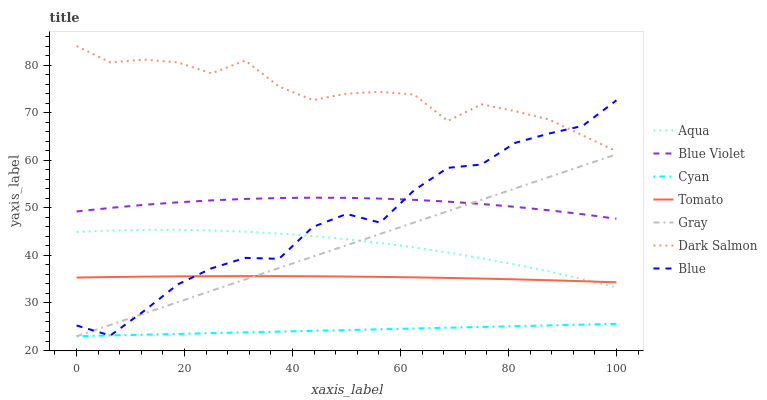Does Cyan have the minimum area under the curve?
Answer yes or no. Yes. Does Dark Salmon have the maximum area under the curve?
Answer yes or no. Yes. Does Gray have the minimum area under the curve?
Answer yes or no. No. Does Gray have the maximum area under the curve?
Answer yes or no. No. Is Cyan the smoothest?
Answer yes or no. Yes. Is Blue the roughest?
Answer yes or no. Yes. Is Gray the smoothest?
Answer yes or no. No. Is Gray the roughest?
Answer yes or no. No. Does Aqua have the lowest value?
Answer yes or no. No. Does Dark Salmon have the highest value?
Answer yes or no. Yes. Does Gray have the highest value?
Answer yes or no. No. Is Cyan less than Tomato?
Answer yes or no. Yes. Is Blue Violet greater than Tomato?
Answer yes or no. Yes. Does Blue intersect Tomato?
Answer yes or no. Yes. Is Blue less than Tomato?
Answer yes or no. No. Is Blue greater than Tomato?
Answer yes or no. No. Does Cyan intersect Tomato?
Answer yes or no. No. 